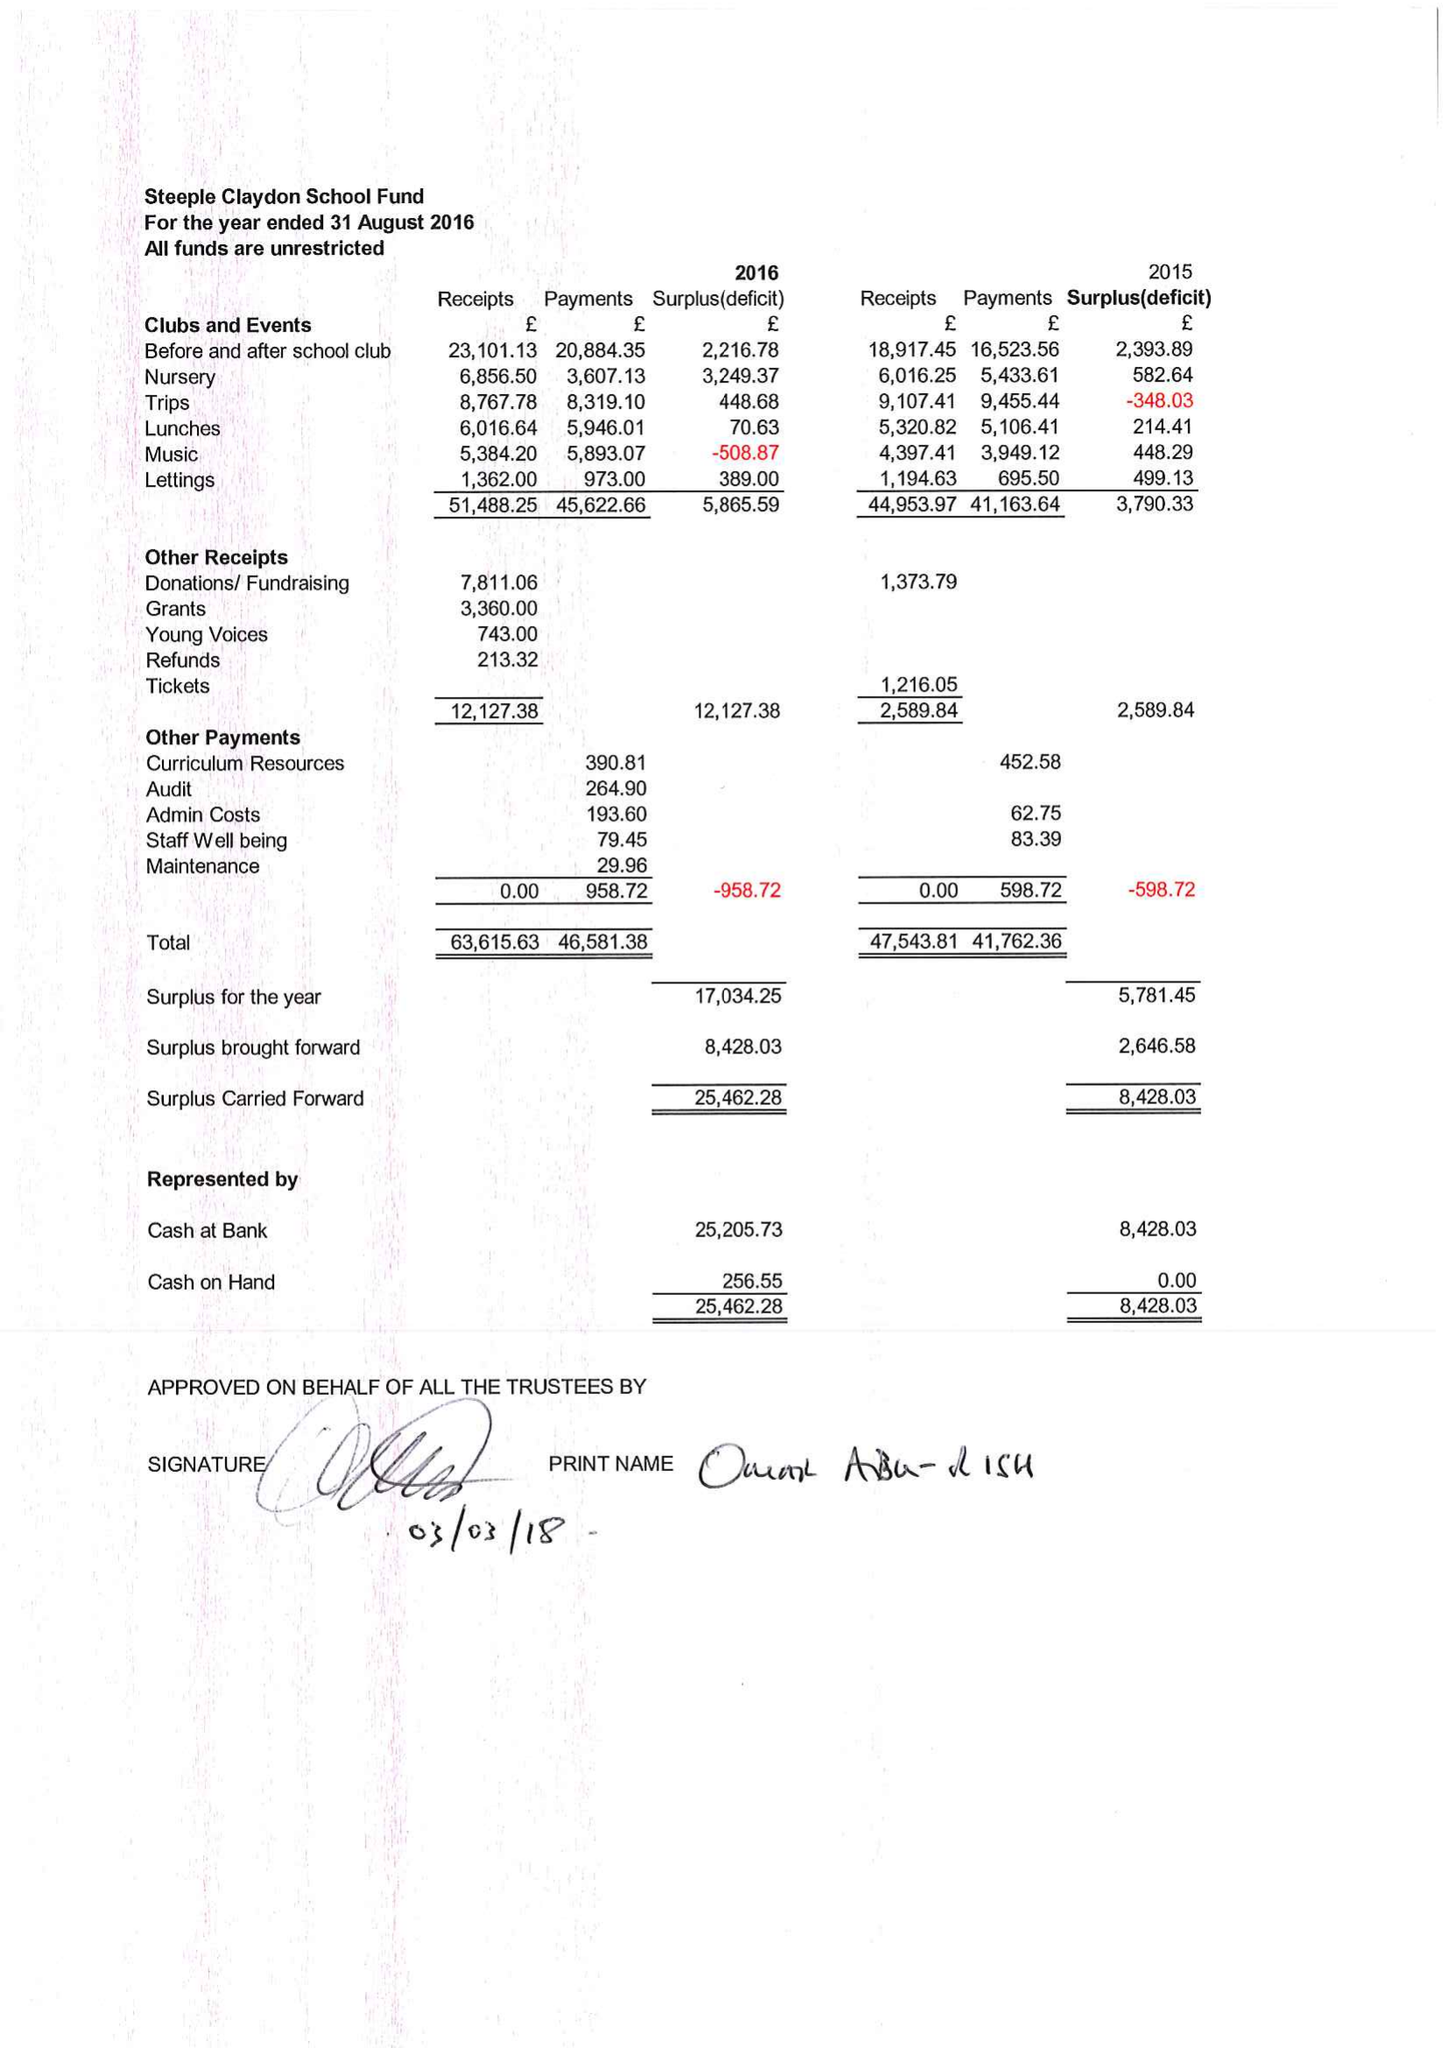What is the value for the spending_annually_in_british_pounds?
Answer the question using a single word or phrase. 46582.00 